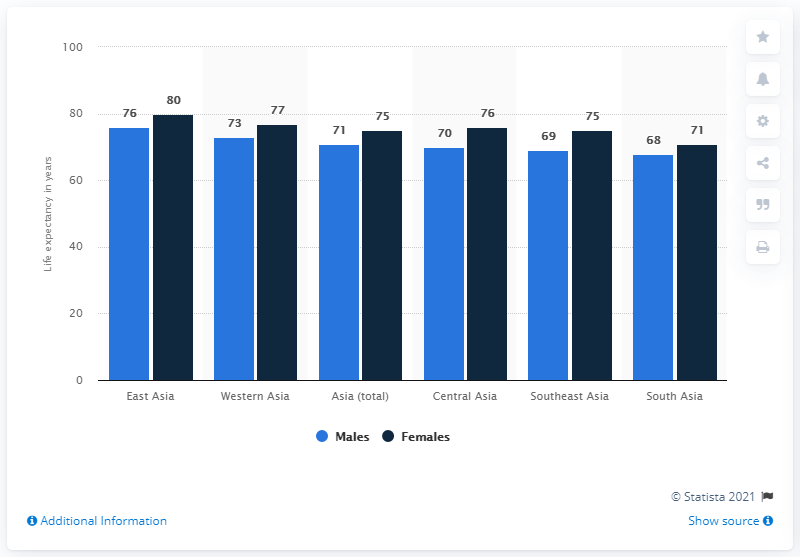How does female life expectancy compare across these regions? Female life expectancy generally surpasses male life expectancy in the depicted regions. For instance, females in East Asia have a life expectancy of 80 years, the highest among the regions, while in South Asia it's 71 years, which is the lowest but still higher than their male counterparts. 